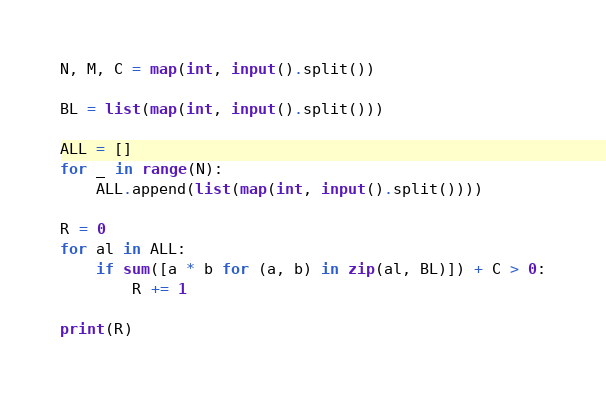<code> <loc_0><loc_0><loc_500><loc_500><_Python_>N, M, C = map(int, input().split())

BL = list(map(int, input().split()))

ALL = []
for _ in range(N):
    ALL.append(list(map(int, input().split())))

R = 0
for al in ALL:
    if sum([a * b for (a, b) in zip(al, BL)]) + C > 0:
        R += 1

print(R)
</code> 